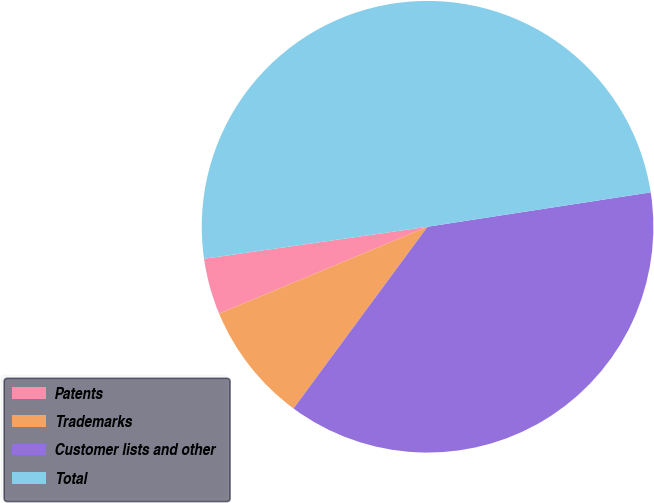Convert chart. <chart><loc_0><loc_0><loc_500><loc_500><pie_chart><fcel>Patents<fcel>Trademarks<fcel>Customer lists and other<fcel>Total<nl><fcel>4.02%<fcel>8.6%<fcel>37.55%<fcel>49.84%<nl></chart> 